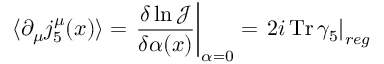<formula> <loc_0><loc_0><loc_500><loc_500>\langle \partial _ { \mu } j _ { 5 } ^ { \mu } ( x ) \rangle = \frac { \delta \ln { \mathcal { J } } } { \delta \alpha ( x ) } \right | _ { \alpha = 0 } = 2 i \, T r \, \gamma _ { 5 } \right | _ { r e g }</formula> 